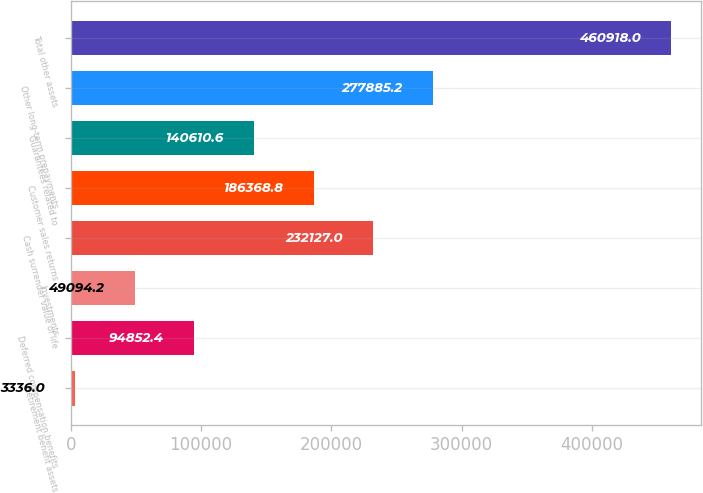Convert chart. <chart><loc_0><loc_0><loc_500><loc_500><bar_chart><fcel>Retirement benefit assets<fcel>Deferred compensation benefits<fcel>Investments<fcel>Cash surrender value of life<fcel>Customer sales returns<fcel>Guarantees related to<fcel>Other long-term prepayments<fcel>Total other assets<nl><fcel>3336<fcel>94852.4<fcel>49094.2<fcel>232127<fcel>186369<fcel>140611<fcel>277885<fcel>460918<nl></chart> 